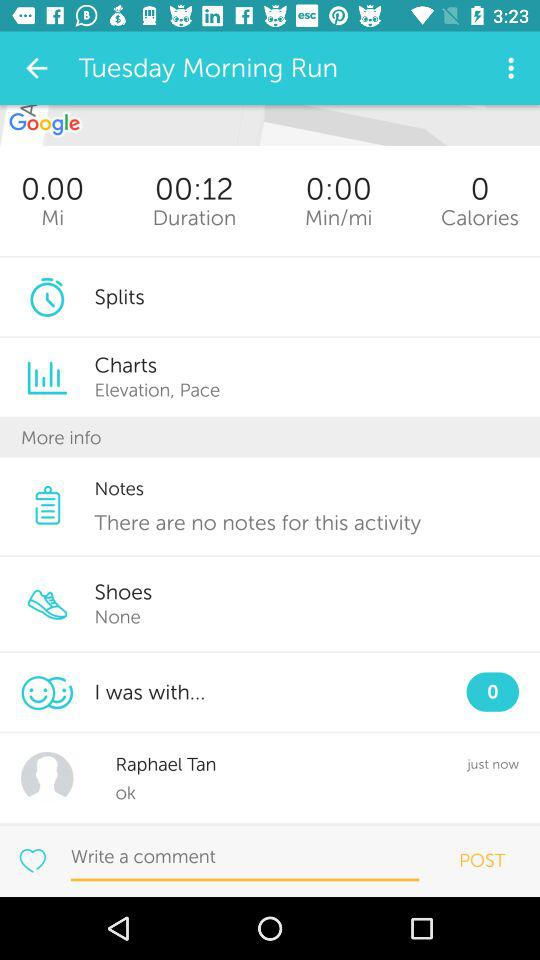How many calories are mentioned? There are 0 calories mentioned. 